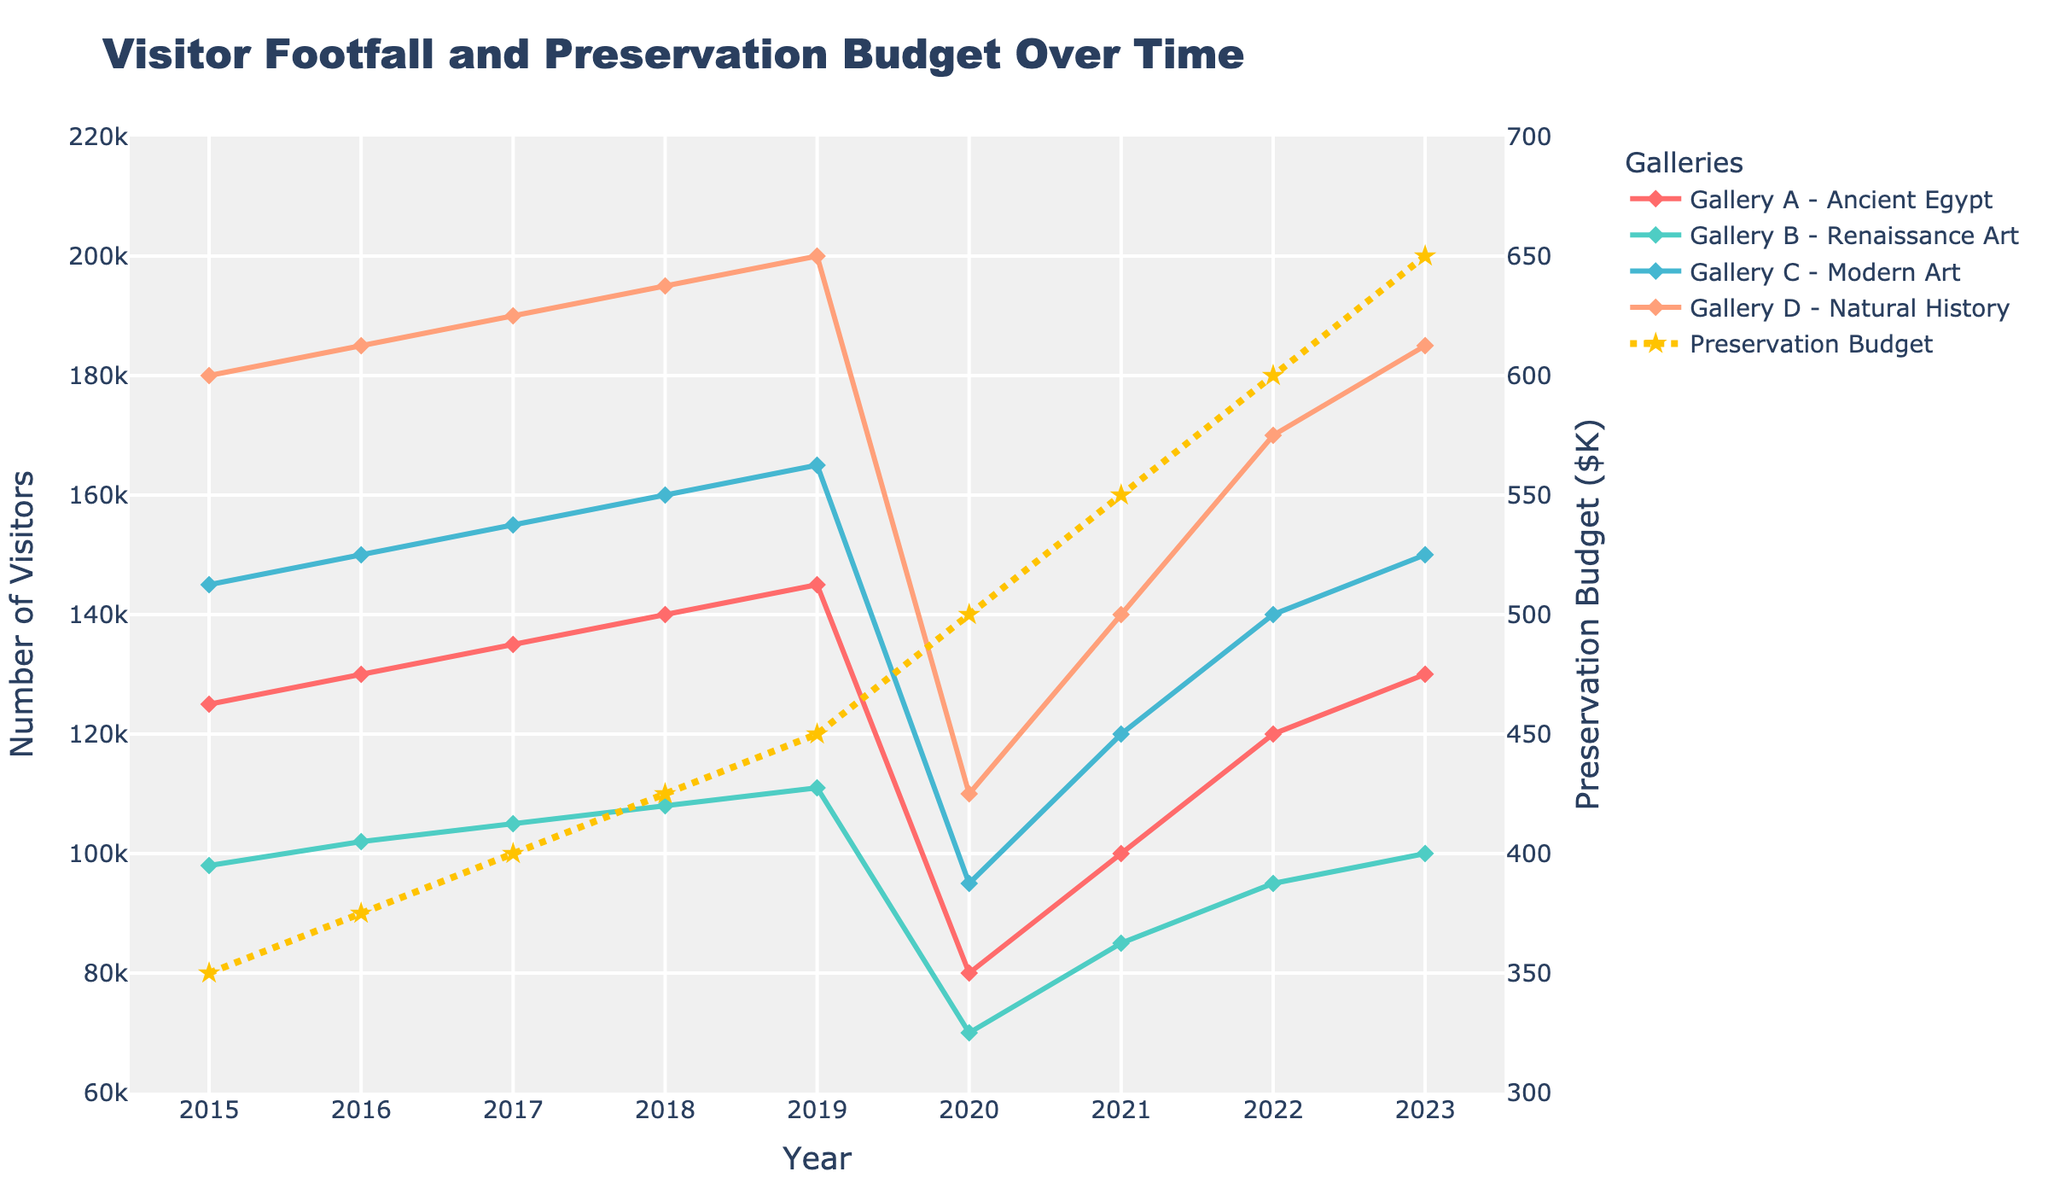what's the highest visitor footfall recorded among all galleries in any year? The highest visitor footfall occurs in Gallery D - Natural History in 2019, reaching 200,000 visitors. This can be identified by looking at the peak of the line representing Gallery D in the plot.
Answer: 200,000 In which year did Gallery A - Ancient Egypt and Gallery B - Renaissance Art record the same visitor footfall? By examining their trends, Gallery A (red line) and Gallery B (green line) intersect in 2023, with both recording 130,000 visitors.
Answer: 2023 How does the visitor footfall in Gallery C - Modern Art in 2020 compare to the previous year? In 2019, Gallery C had 165,000 visitors. In 2020, it dropped to 95,000. The difference is 165,000 - 95,000 = 70,000, indicating a significant decrease.
Answer: 70,000 less How did the preservation budget change from 2015 to 2023? The preservation budget in 2015 was $350K and in 2023 it increased to $650K. The difference is $650K - $350K = $300K. The budget increased by $300K over this period.
Answer: $300K increase What is the average visitor footfall for Gallery B - Renaissance Art over the years? Sum the visitor footfalls from 2015-2023 for Gallery B: 98,000 + 102,000 + 105,000 + 108,000 + 111,000 + 70,000 + 85,000 + 95,000 + 100,000 = 774,000. Divide by 9 years to get the average: 774,000 / 9 = 86,000.
Answer: 86,000 Which gallery experienced the most significant drop in visitor footfall in 2020 compared to 2019? Compare all galleries' visitor footfalls between 2019 and 2020. Gallery D (Natural History) dropped from 200,000 in 2019 to 110,000 in 2020, a difference of 90,000, which is the highest among all galleries.
Answer: Gallery D - Natural History In which year did the preservation budget cross the $500K mark? Observing the trend line for the preservation budget (yellow dashed line), it crosses $500K in 2020 when the budget is $500K.
Answer: 2020 What is the total visitor footfall in 2022 across all galleries? Add the visitor footfalls for all galleries in 2022: 120,000 (Gallery A) + 95,000 (Gallery B) + 140,000 (Gallery C) + 170,000 (Gallery D) = 525,000.
Answer: 525,000 What visual trend can you observe about visitor footfall in the year 2020? There is a noticeable sharp decline in visitor footfalls across all galleries in 2020, as indicated by the steep downward slopes in all the lines representing the galleries.
Answer: Sharp decline Compare the visitor footfall trends for Gallery A - Ancient Egypt from 2015 to 2023 with the preservation budget trend. Gallery A’s visitor footfall generally increases from 125,000 in 2015 to 130,000 in 2023, except for a dip in 2020. The preservation budget consistently rises from $350K to $650K without such a dip in 2020. Thus, visitor footfall dips in 2020, while the preservation budget does not.
Answer: Gallery A dips in 2020; budget rises continuously 